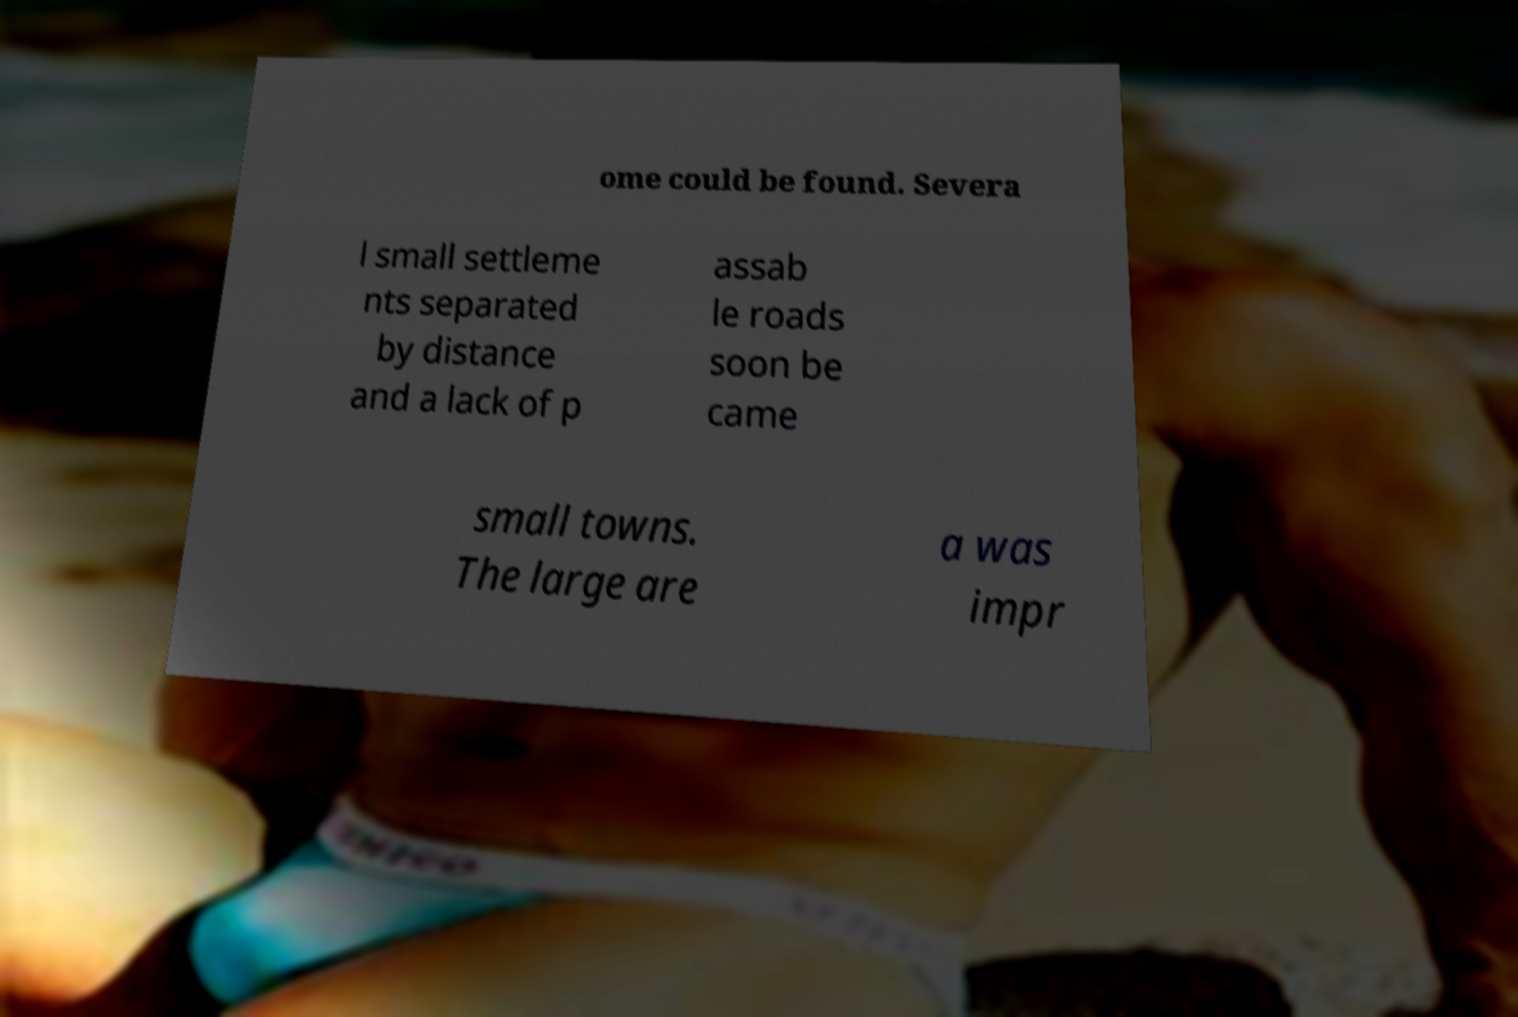Can you accurately transcribe the text from the provided image for me? ome could be found. Severa l small settleme nts separated by distance and a lack of p assab le roads soon be came small towns. The large are a was impr 